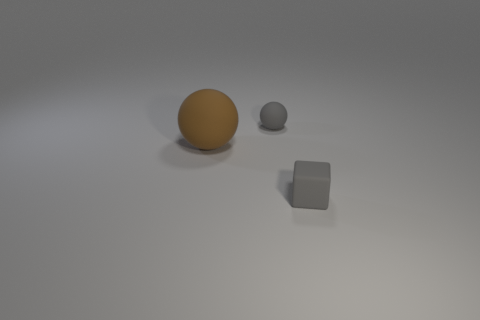Is the number of purple matte things greater than the number of tiny gray matte things?
Make the answer very short. No. There is a rubber ball that is left of the small rubber thing that is to the left of the gray matte block; are there any brown things to the left of it?
Provide a succinct answer. No. How many other objects are there of the same size as the gray matte sphere?
Provide a succinct answer. 1. Are there any big balls in front of the gray matte sphere?
Your answer should be very brief. Yes. There is a tiny matte sphere; is its color the same as the thing that is in front of the brown thing?
Make the answer very short. Yes. What is the color of the small rubber object that is on the left side of the rubber thing that is to the right of the tiny matte sphere behind the gray block?
Your response must be concise. Gray. Are there any gray things of the same shape as the brown object?
Make the answer very short. Yes. What color is the sphere that is the same size as the gray matte cube?
Ensure brevity in your answer.  Gray. There is a gray object left of the tiny gray block; what is it made of?
Offer a terse response. Rubber. Do the matte thing that is behind the big brown rubber thing and the small gray object in front of the big rubber sphere have the same shape?
Give a very brief answer. No. 